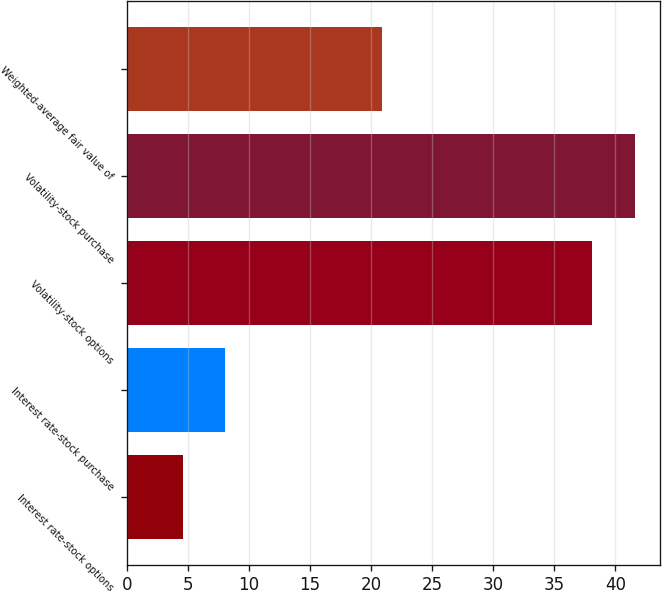Convert chart to OTSL. <chart><loc_0><loc_0><loc_500><loc_500><bar_chart><fcel>Interest rate-stock options<fcel>Interest rate-stock purchase<fcel>Volatility-stock options<fcel>Volatility-stock purchase<fcel>Weighted-average fair value of<nl><fcel>4.61<fcel>8.07<fcel>38.13<fcel>41.59<fcel>20.9<nl></chart> 